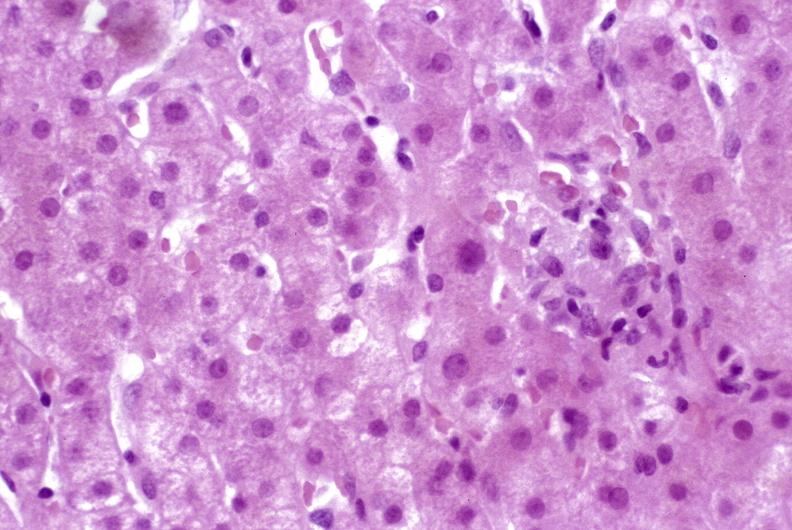s lesion in dome of uterus present?
Answer the question using a single word or phrase. No 